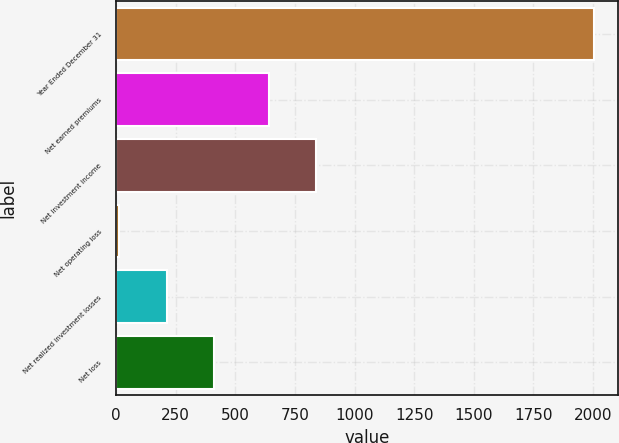Convert chart to OTSL. <chart><loc_0><loc_0><loc_500><loc_500><bar_chart><fcel>Year Ended December 31<fcel>Net earned premiums<fcel>Net investment income<fcel>Net operating loss<fcel>Net realized investment losses<fcel>Net loss<nl><fcel>2006<fcel>641<fcel>840.3<fcel>13<fcel>212.3<fcel>411.6<nl></chart> 